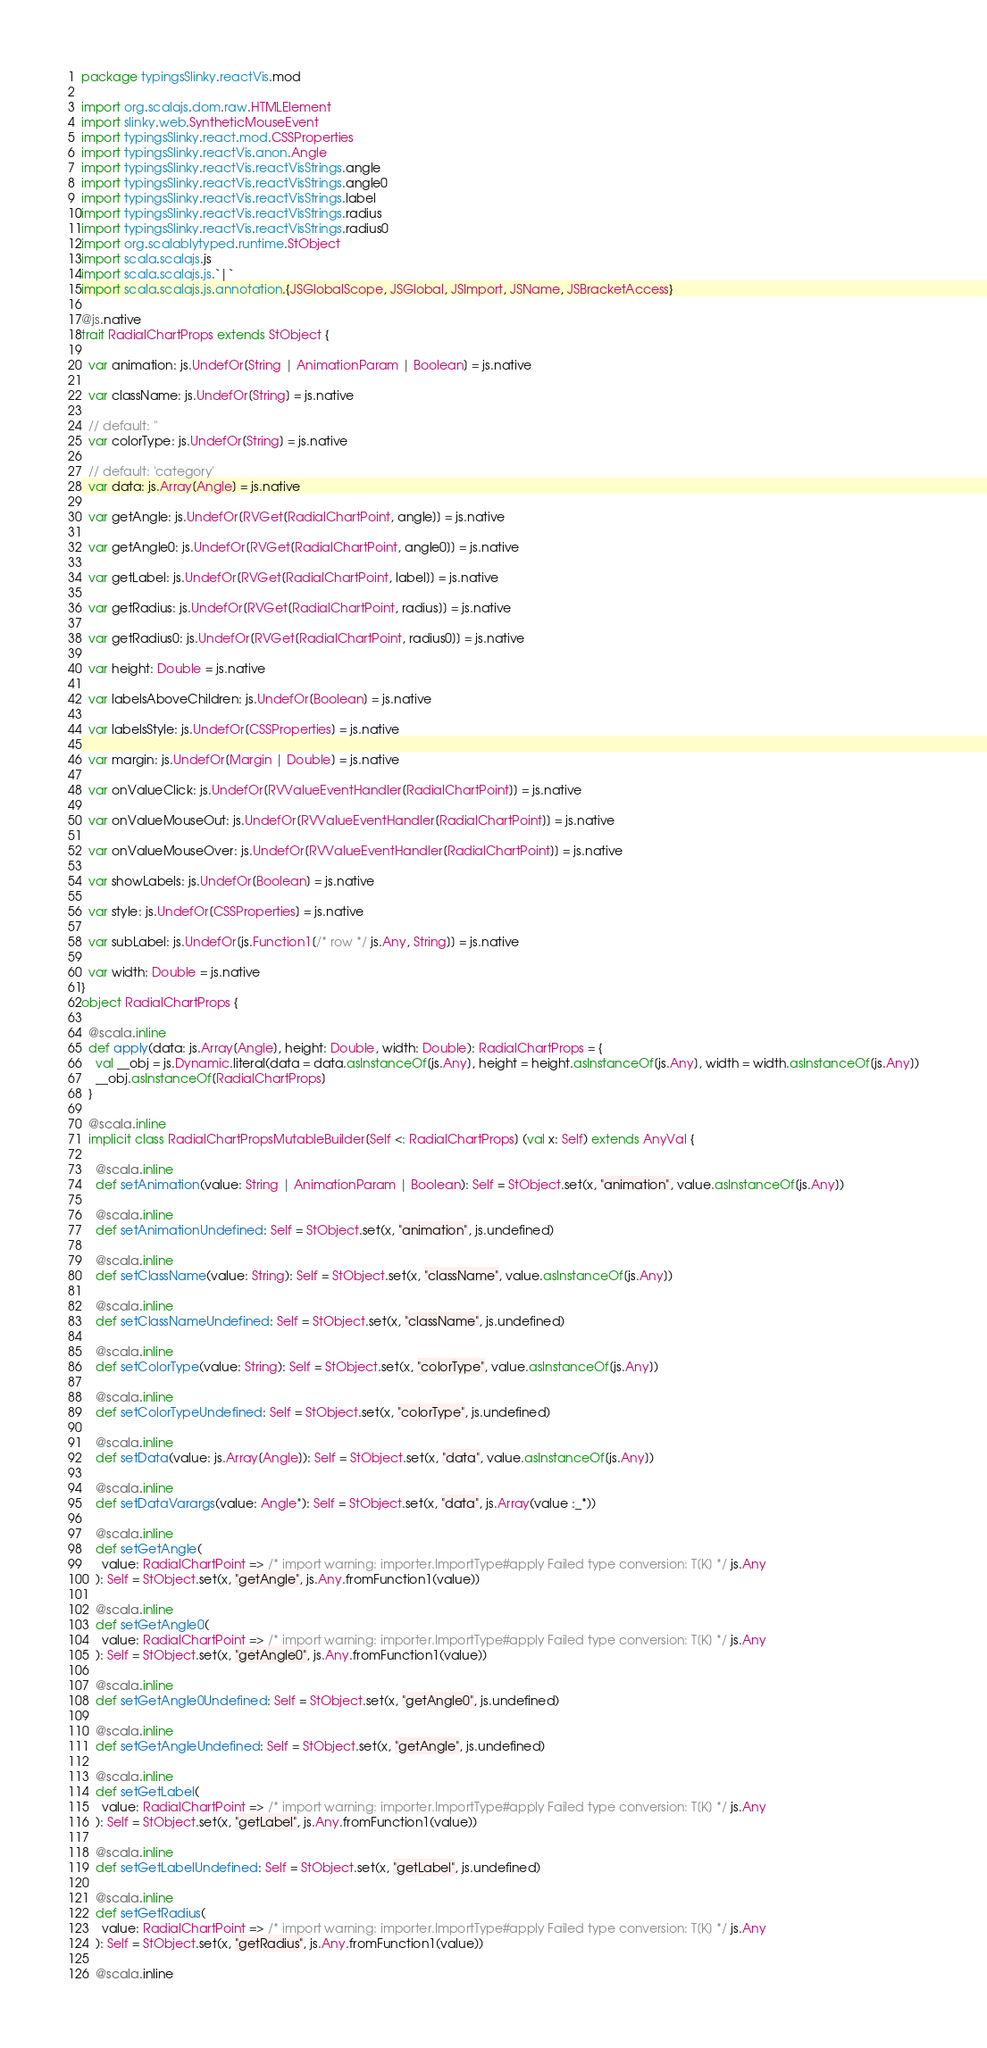<code> <loc_0><loc_0><loc_500><loc_500><_Scala_>package typingsSlinky.reactVis.mod

import org.scalajs.dom.raw.HTMLElement
import slinky.web.SyntheticMouseEvent
import typingsSlinky.react.mod.CSSProperties
import typingsSlinky.reactVis.anon.Angle
import typingsSlinky.reactVis.reactVisStrings.angle
import typingsSlinky.reactVis.reactVisStrings.angle0
import typingsSlinky.reactVis.reactVisStrings.label
import typingsSlinky.reactVis.reactVisStrings.radius
import typingsSlinky.reactVis.reactVisStrings.radius0
import org.scalablytyped.runtime.StObject
import scala.scalajs.js
import scala.scalajs.js.`|`
import scala.scalajs.js.annotation.{JSGlobalScope, JSGlobal, JSImport, JSName, JSBracketAccess}

@js.native
trait RadialChartProps extends StObject {
  
  var animation: js.UndefOr[String | AnimationParam | Boolean] = js.native
  
  var className: js.UndefOr[String] = js.native
  
  // default: ''
  var colorType: js.UndefOr[String] = js.native
  
  // default: 'category'
  var data: js.Array[Angle] = js.native
  
  var getAngle: js.UndefOr[RVGet[RadialChartPoint, angle]] = js.native
  
  var getAngle0: js.UndefOr[RVGet[RadialChartPoint, angle0]] = js.native
  
  var getLabel: js.UndefOr[RVGet[RadialChartPoint, label]] = js.native
  
  var getRadius: js.UndefOr[RVGet[RadialChartPoint, radius]] = js.native
  
  var getRadius0: js.UndefOr[RVGet[RadialChartPoint, radius0]] = js.native
  
  var height: Double = js.native
  
  var labelsAboveChildren: js.UndefOr[Boolean] = js.native
  
  var labelsStyle: js.UndefOr[CSSProperties] = js.native
  
  var margin: js.UndefOr[Margin | Double] = js.native
  
  var onValueClick: js.UndefOr[RVValueEventHandler[RadialChartPoint]] = js.native
  
  var onValueMouseOut: js.UndefOr[RVValueEventHandler[RadialChartPoint]] = js.native
  
  var onValueMouseOver: js.UndefOr[RVValueEventHandler[RadialChartPoint]] = js.native
  
  var showLabels: js.UndefOr[Boolean] = js.native
  
  var style: js.UndefOr[CSSProperties] = js.native
  
  var subLabel: js.UndefOr[js.Function1[/* row */ js.Any, String]] = js.native
  
  var width: Double = js.native
}
object RadialChartProps {
  
  @scala.inline
  def apply(data: js.Array[Angle], height: Double, width: Double): RadialChartProps = {
    val __obj = js.Dynamic.literal(data = data.asInstanceOf[js.Any], height = height.asInstanceOf[js.Any], width = width.asInstanceOf[js.Any])
    __obj.asInstanceOf[RadialChartProps]
  }
  
  @scala.inline
  implicit class RadialChartPropsMutableBuilder[Self <: RadialChartProps] (val x: Self) extends AnyVal {
    
    @scala.inline
    def setAnimation(value: String | AnimationParam | Boolean): Self = StObject.set(x, "animation", value.asInstanceOf[js.Any])
    
    @scala.inline
    def setAnimationUndefined: Self = StObject.set(x, "animation", js.undefined)
    
    @scala.inline
    def setClassName(value: String): Self = StObject.set(x, "className", value.asInstanceOf[js.Any])
    
    @scala.inline
    def setClassNameUndefined: Self = StObject.set(x, "className", js.undefined)
    
    @scala.inline
    def setColorType(value: String): Self = StObject.set(x, "colorType", value.asInstanceOf[js.Any])
    
    @scala.inline
    def setColorTypeUndefined: Self = StObject.set(x, "colorType", js.undefined)
    
    @scala.inline
    def setData(value: js.Array[Angle]): Self = StObject.set(x, "data", value.asInstanceOf[js.Any])
    
    @scala.inline
    def setDataVarargs(value: Angle*): Self = StObject.set(x, "data", js.Array(value :_*))
    
    @scala.inline
    def setGetAngle(
      value: RadialChartPoint => /* import warning: importer.ImportType#apply Failed type conversion: T[K] */ js.Any
    ): Self = StObject.set(x, "getAngle", js.Any.fromFunction1(value))
    
    @scala.inline
    def setGetAngle0(
      value: RadialChartPoint => /* import warning: importer.ImportType#apply Failed type conversion: T[K] */ js.Any
    ): Self = StObject.set(x, "getAngle0", js.Any.fromFunction1(value))
    
    @scala.inline
    def setGetAngle0Undefined: Self = StObject.set(x, "getAngle0", js.undefined)
    
    @scala.inline
    def setGetAngleUndefined: Self = StObject.set(x, "getAngle", js.undefined)
    
    @scala.inline
    def setGetLabel(
      value: RadialChartPoint => /* import warning: importer.ImportType#apply Failed type conversion: T[K] */ js.Any
    ): Self = StObject.set(x, "getLabel", js.Any.fromFunction1(value))
    
    @scala.inline
    def setGetLabelUndefined: Self = StObject.set(x, "getLabel", js.undefined)
    
    @scala.inline
    def setGetRadius(
      value: RadialChartPoint => /* import warning: importer.ImportType#apply Failed type conversion: T[K] */ js.Any
    ): Self = StObject.set(x, "getRadius", js.Any.fromFunction1(value))
    
    @scala.inline</code> 